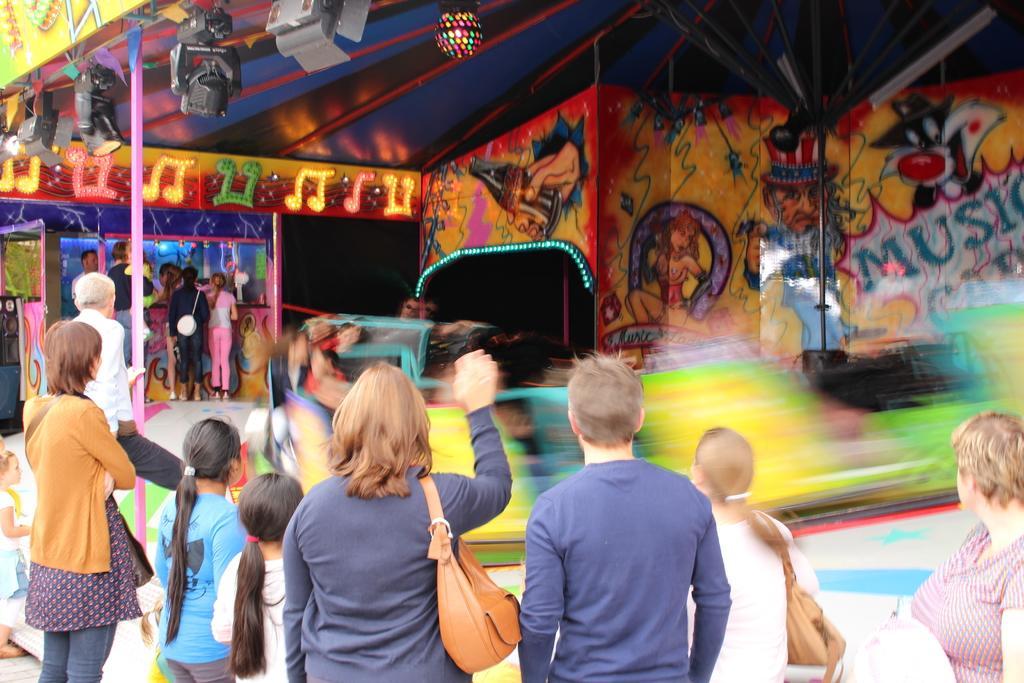Can you describe this image briefly? In this image I can see group of people standing. In the background I can see few stalls, few lights, cameras and I can see the wall in multi color. 